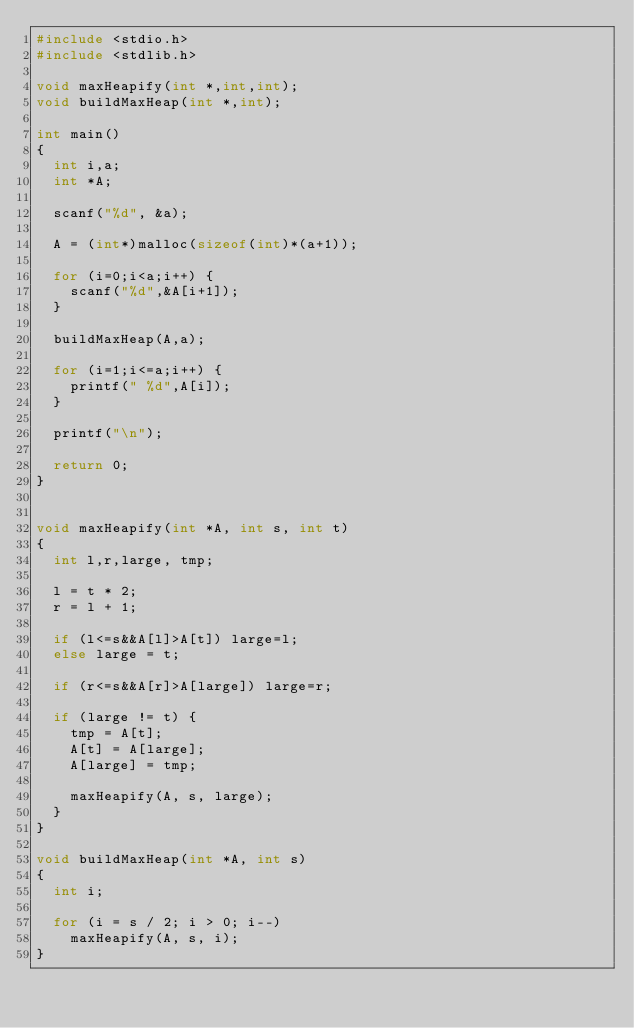Convert code to text. <code><loc_0><loc_0><loc_500><loc_500><_C_>#include <stdio.h>
#include <stdlib.h>

void maxHeapify(int *,int,int);
void buildMaxHeap(int *,int);

int main()
{
  int i,a;
  int *A;

  scanf("%d", &a);
  
  A = (int*)malloc(sizeof(int)*(a+1));
  
  for (i=0;i<a;i++) {
    scanf("%d",&A[i+1]);
  }

  buildMaxHeap(A,a);

  for (i=1;i<=a;i++) {
    printf(" %d",A[i]);
  }

  printf("\n");

  return 0;
}


void maxHeapify(int *A, int s, int t)
{
  int l,r,large, tmp;
  
  l = t * 2;
  r = l + 1;

  if (l<=s&&A[l]>A[t]) large=l;
  else large = t;

  if (r<=s&&A[r]>A[large]) large=r;

  if (large != t) {
    tmp = A[t];
    A[t] = A[large];
    A[large] = tmp;

    maxHeapify(A, s, large);
  }
}

void buildMaxHeap(int *A, int s)
{
  int i;
  
  for (i = s / 2; i > 0; i--)
    maxHeapify(A, s, i);
}

</code> 